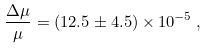<formula> <loc_0><loc_0><loc_500><loc_500>\frac { \Delta \mu } { \mu } = ( 1 2 . 5 \pm 4 . 5 ) \times 1 0 ^ { - 5 } \, ,</formula> 